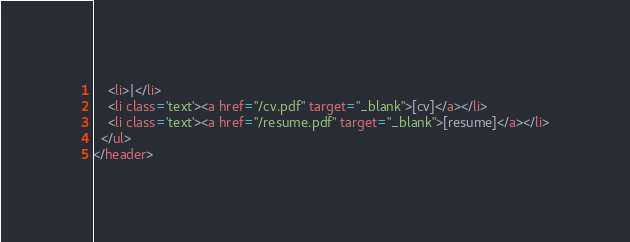<code> <loc_0><loc_0><loc_500><loc_500><_HTML_>    <li>|</li>
    <li class='text'><a href="/cv.pdf" target="_blank">[cv]</a></li>
    <li class='text'><a href="/resume.pdf" target="_blank">[resume]</a></li>
  </ul>
</header>
</code> 